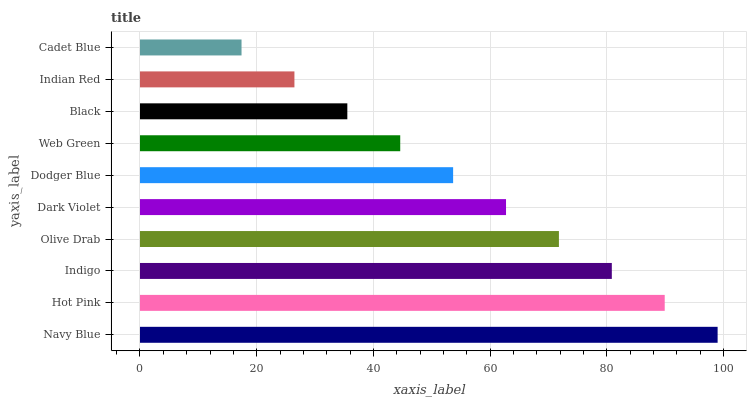Is Cadet Blue the minimum?
Answer yes or no. Yes. Is Navy Blue the maximum?
Answer yes or no. Yes. Is Hot Pink the minimum?
Answer yes or no. No. Is Hot Pink the maximum?
Answer yes or no. No. Is Navy Blue greater than Hot Pink?
Answer yes or no. Yes. Is Hot Pink less than Navy Blue?
Answer yes or no. Yes. Is Hot Pink greater than Navy Blue?
Answer yes or no. No. Is Navy Blue less than Hot Pink?
Answer yes or no. No. Is Dark Violet the high median?
Answer yes or no. Yes. Is Dodger Blue the low median?
Answer yes or no. Yes. Is Navy Blue the high median?
Answer yes or no. No. Is Cadet Blue the low median?
Answer yes or no. No. 